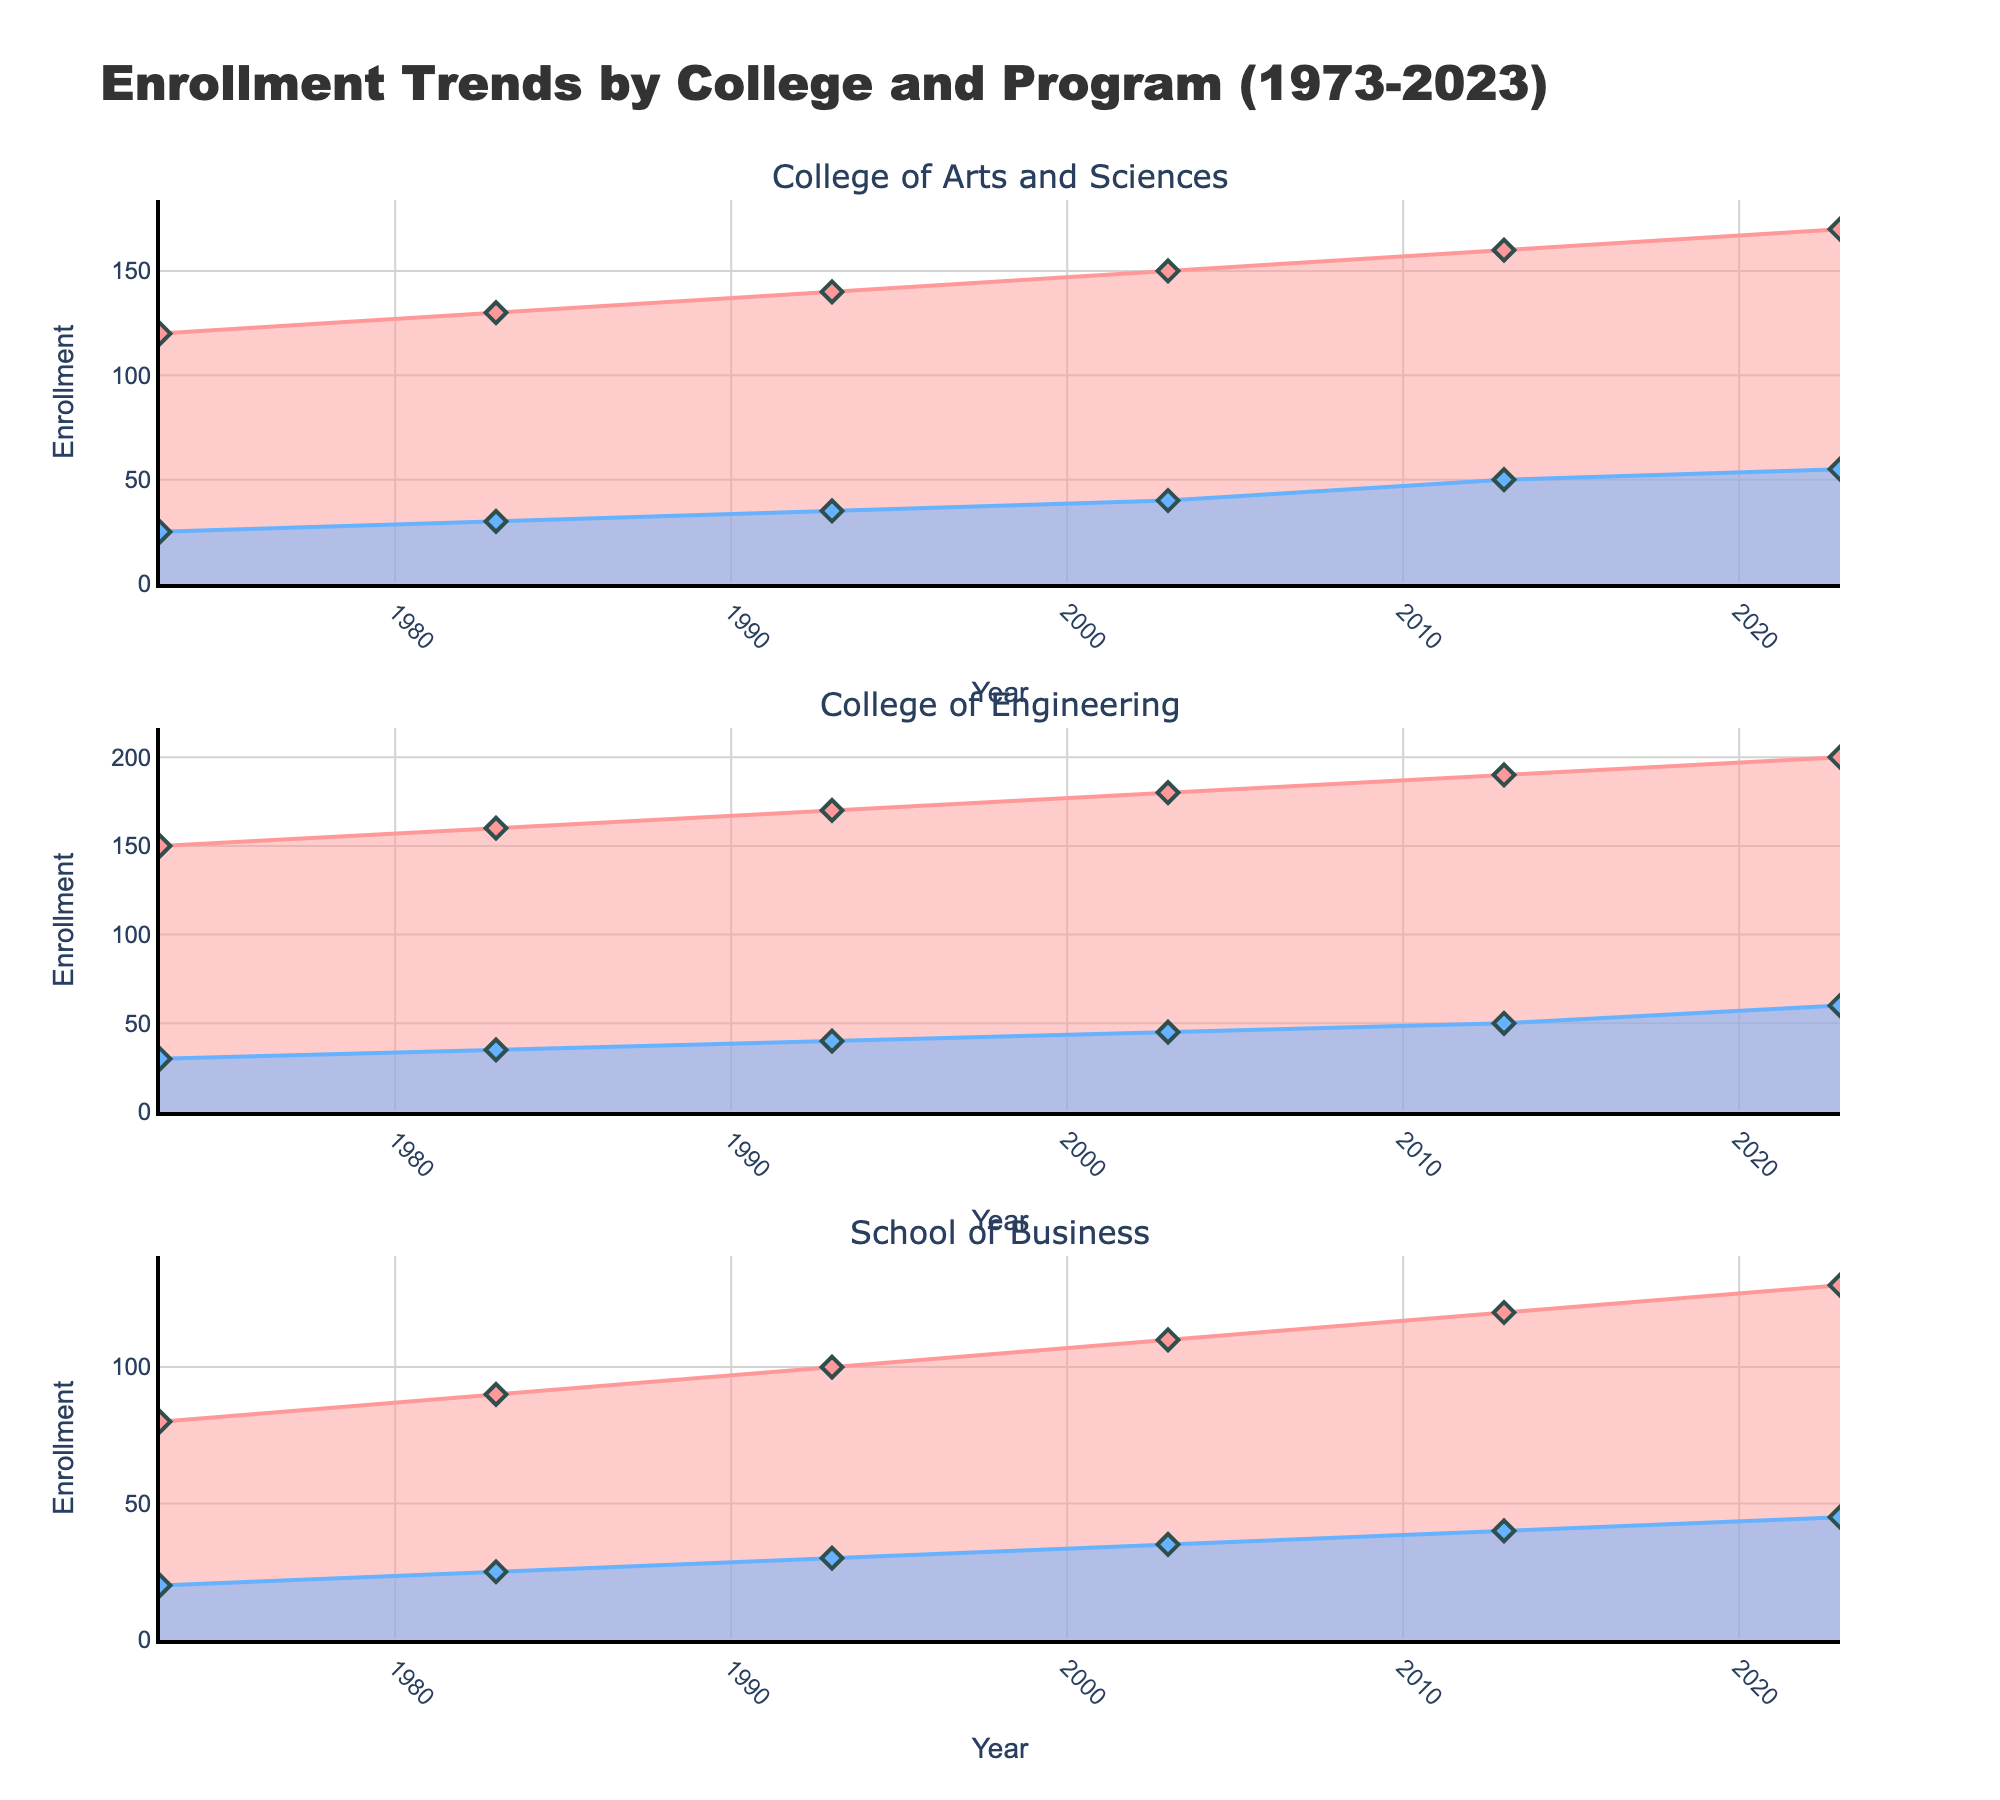What is the total enrollment for the College of Arts and Sciences in 2023? To find the total enrollment for the College of Arts and Sciences in 2023, add the undergraduate and graduate enrollment numbers: 170 (undergraduate) + 55 (graduate) = 225.
Answer: 225 How did the number of undergraduate enrollments in the School of Business change from 1973 to 2023? In 1973, the undergraduate enrollment for the School of Business was 80. In 2023, it was 130. To find the change, subtract the 1973 value from the 2023 value: 130 - 80 = 50.
Answer: Increased by 50 Which college had the highest graduate enrollment in 2013? To determine which college had the highest graduate enrollment in 2013, compare the graduate enrollment numbers: College of Arts and Sciences (50), College of Engineering (50), School of Business (40). College of Arts and Sciences and College of Engineering both have the highest at 50.
Answer: College of Arts and Sciences and College of Engineering What is the difference in undergraduate enrollment between the College of Engineering and the College of Arts and Sciences in 2003? In 2003, the undergraduate enrollment for the College of Engineering was 180. For the College of Arts and Sciences, it was 150. The difference is found by subtracting the smaller number from the larger: 180 - 150 = 30.
Answer: 30 What trend is observed in the graduate enrollment for the College of Engineering from 1973 to 2023? We observe the graduate enrollment values for the College of Engineering across the years: 1973 (30), 1983 (35), 1993 (40), 2003 (45), 2013 (50), 2023 (60). The trend shows a consistent increase in graduate enrollments over these years.
Answer: Consistent increase Is there any year when the undergraduate enrollment in the College of Arts and Sciences decreased compared to the previous decade? By looking at the undergraduate enrollments for the College of Arts and Sciences over the years: 1973 (120), 1983 (130), 1993 (140), 2003 (150), 2013 (160), 2023 (170), there is no year where there is a decrease compared to the previous decade.
Answer: No Compare the undergraduate enrollments of Civil Engineering in 1993 and Electrical Engineering in 2013. Which has higher enrollment? From the figure, undergraduate enrollment for Civil Engineering in 1993 is 170, and for Electrical Engineering in 2013, it is 190. Comparing these values, Electrical Engineering in 2013 has higher enrollment.
Answer: Electrical Engineering in 2013 In which decade did the School of Business see the largest increase in undergraduate enrollment for a single program? We compare the increases in undergraduate enrollments each decade for the School of Business: 1973-1983 (10 for Finance), 1983-1993 (10 for Accounting), 1993-2003 (10 for Accounting), 2003-2013 (10 for Marketing), 2013-2023 (10 for Management). Since all increases are incremental by 10, no single decade saw the largest increase.
Answer: None 